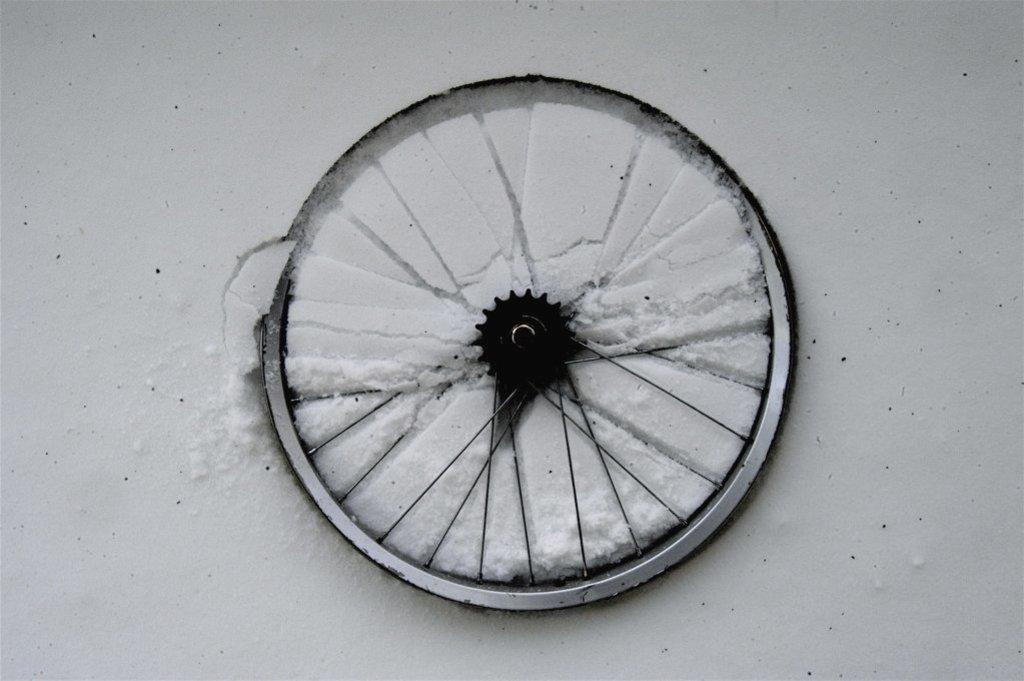What is the main object in the image? There is a wheel in the image. What color is the background of the image? The background of the image is white. Can you describe the ground in the image? It appears that there is snow on the ground in the image. How many ants can be seen crawling on the wheel in the image? There are no ants present in the image; it only features a wheel and a white background. 